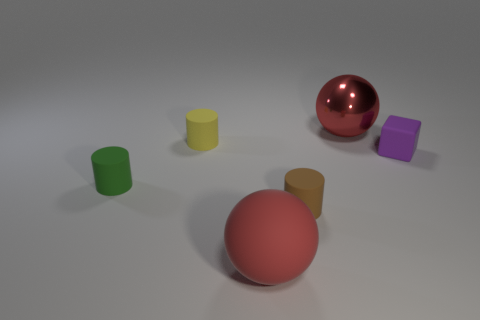How many objects are there, and can you describe their arrangement? There are five objects in the image, arranged with ample space between them. Two objects appear to be spherical, located in the foreground, while three cylindrical objects are evenly spaced in the background. 